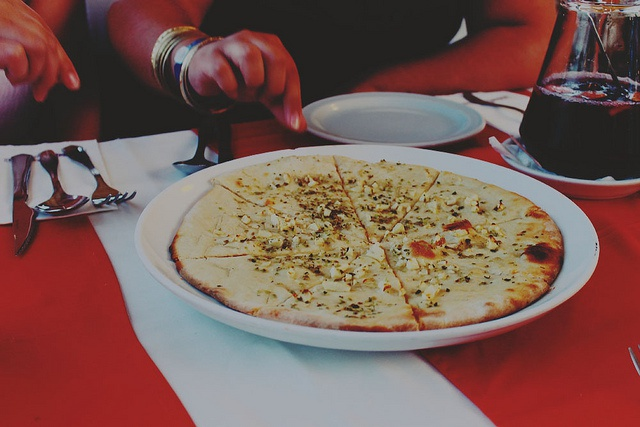Describe the objects in this image and their specific colors. I can see dining table in darkgray, brown, tan, and black tones, pizza in brown, tan, darkgray, and olive tones, people in brown, black, and maroon tones, people in brown and maroon tones, and knife in brown, maroon, black, and purple tones in this image. 